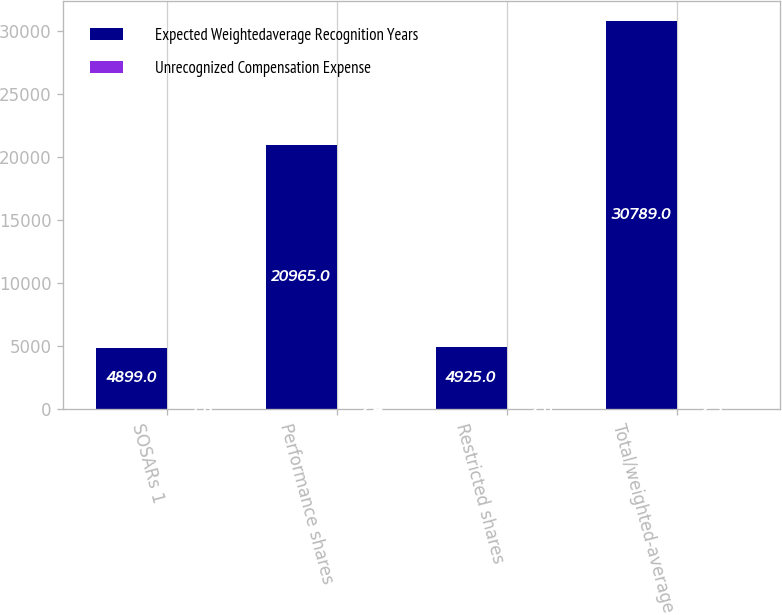Convert chart to OTSL. <chart><loc_0><loc_0><loc_500><loc_500><stacked_bar_chart><ecel><fcel>SOSARs 1<fcel>Performance shares<fcel>Restricted shares<fcel>Total/weighted-average<nl><fcel>Expected Weightedaverage Recognition Years<fcel>4899<fcel>20965<fcel>4925<fcel>30789<nl><fcel>Unrecognized Compensation Expense<fcel>1.8<fcel>2.4<fcel>2.6<fcel>2.3<nl></chart> 